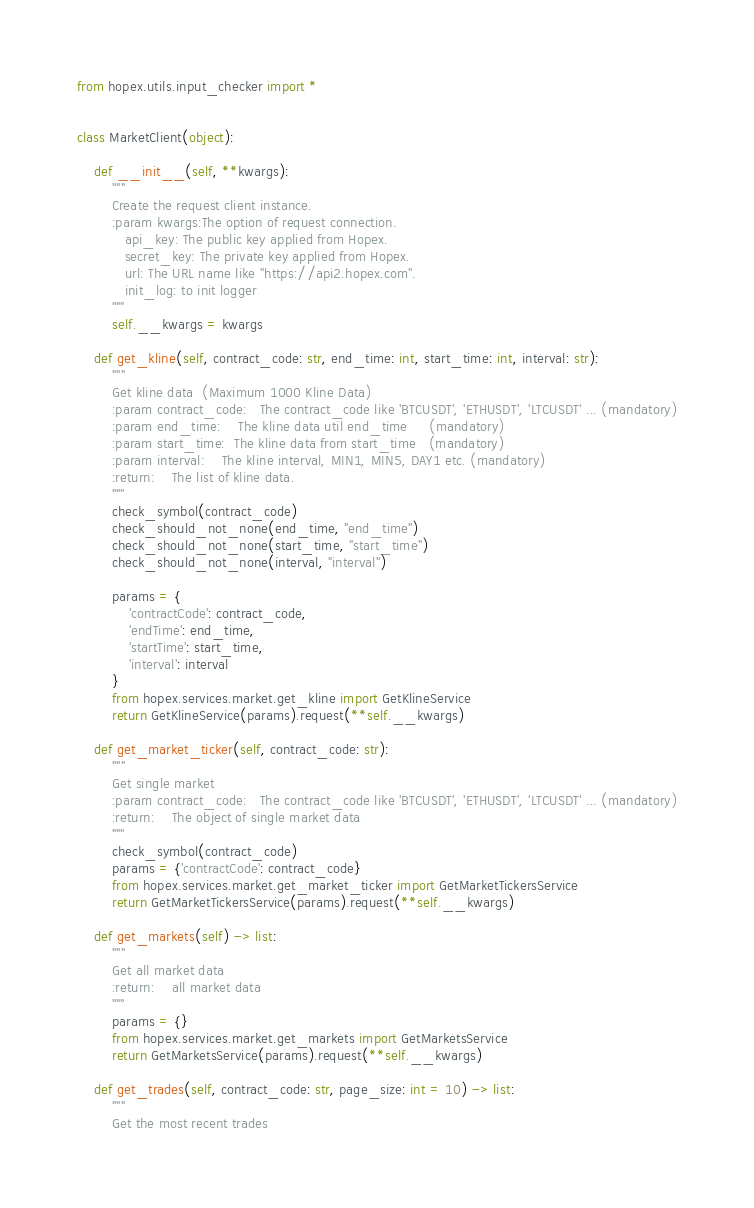<code> <loc_0><loc_0><loc_500><loc_500><_Python_>from hopex.utils.input_checker import *


class MarketClient(object):

    def __init__(self, **kwargs):
        """
        Create the request client instance.
        :param kwargs:The option of request connection.
           api_key: The public key applied from Hopex.
           secret_key: The private key applied from Hopex.
           url: The URL name like "https://api2.hopex.com".
           init_log: to init logger
        """
        self.__kwargs = kwargs

    def get_kline(self, contract_code: str, end_time: int, start_time: int, interval: str):
        """
        Get kline data  (Maximum 1000 Kline Data)
        :param contract_code:   The contract_code like 'BTCUSDT', 'ETHUSDT', 'LTCUSDT' ... (mandatory)
        :param end_time:    The kline data util end_time     (mandatory)
        :param start_time:  The kline data from start_time   (mandatory)
        :param interval:    The kline interval, MIN1, MIN5, DAY1 etc. (mandatory)
        :return:    The list of kline data.
        """
        check_symbol(contract_code)
        check_should_not_none(end_time, "end_time")
        check_should_not_none(start_time, "start_time")
        check_should_not_none(interval, "interval")

        params = {
            'contractCode': contract_code,
            'endTime': end_time,
            'startTime': start_time,
            'interval': interval
        }
        from hopex.services.market.get_kline import GetKlineService
        return GetKlineService(params).request(**self.__kwargs)

    def get_market_ticker(self, contract_code: str):
        """
        Get single market
        :param contract_code:   The contract_code like 'BTCUSDT', 'ETHUSDT', 'LTCUSDT' ... (mandatory)
        :return:    The object of single market data
        """
        check_symbol(contract_code)
        params = {'contractCode': contract_code}
        from hopex.services.market.get_market_ticker import GetMarketTickersService
        return GetMarketTickersService(params).request(**self.__kwargs)

    def get_markets(self) -> list:
        """
        Get all market data
        :return:    all market data
        """
        params = {}
        from hopex.services.market.get_markets import GetMarketsService
        return GetMarketsService(params).request(**self.__kwargs)

    def get_trades(self, contract_code: str, page_size: int = 10) -> list:
        """
        Get the most recent trades</code> 